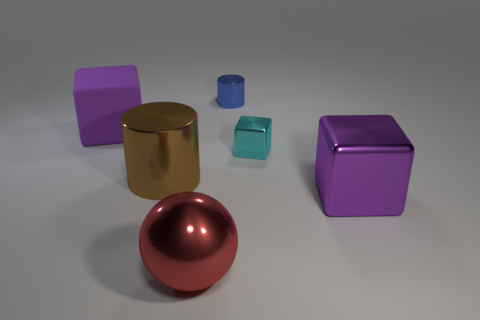Are there any cyan metallic balls of the same size as the red object?
Offer a terse response. No. There is a cylinder that is to the left of the big sphere; what is its size?
Keep it short and to the point. Large. What size is the rubber cube?
Keep it short and to the point. Large. What number of cylinders are large purple rubber things or big metallic things?
Your answer should be compact. 1. What size is the brown object that is the same material as the red object?
Offer a terse response. Large. What number of things are the same color as the large rubber block?
Give a very brief answer. 1. There is a large ball; are there any cylinders right of it?
Provide a succinct answer. Yes. Do the small blue shiny object and the big brown shiny object to the left of the cyan object have the same shape?
Offer a terse response. Yes. What number of things are either large purple shiny blocks to the right of the ball or tiny blue metallic things?
Your answer should be compact. 2. Is there any other thing that has the same material as the large cylinder?
Ensure brevity in your answer.  Yes. 